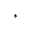<formula> <loc_0><loc_0><loc_500><loc_500>\ast</formula> 